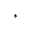<formula> <loc_0><loc_0><loc_500><loc_500>\ast</formula> 